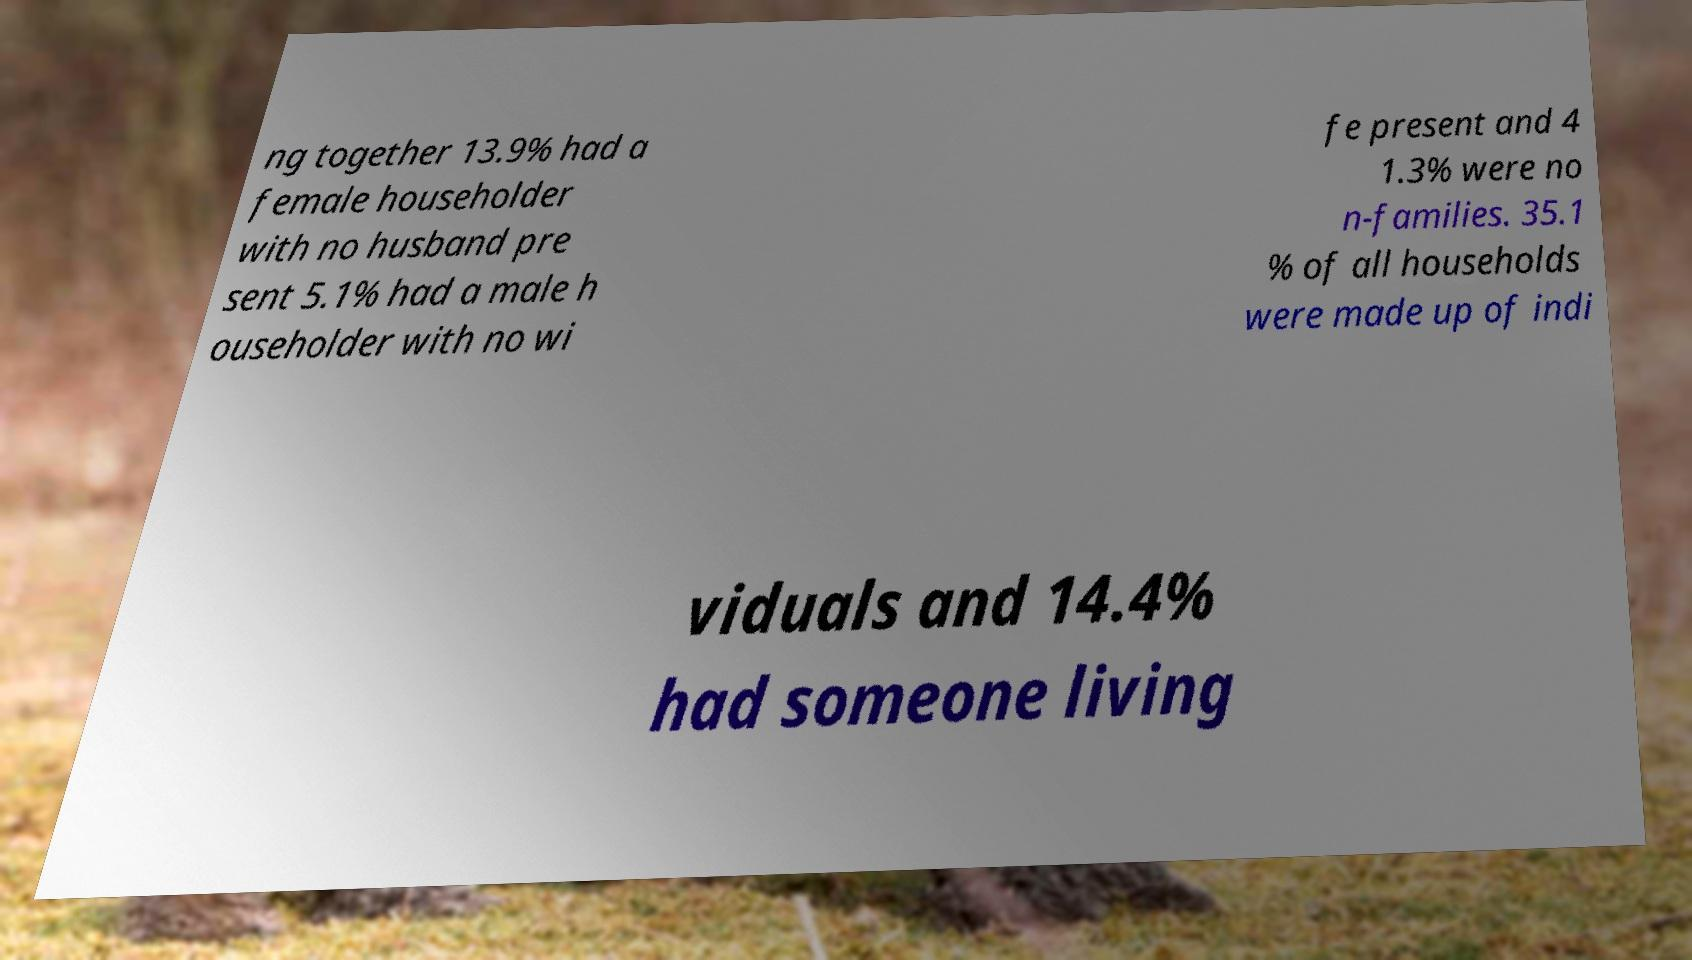Could you extract and type out the text from this image? ng together 13.9% had a female householder with no husband pre sent 5.1% had a male h ouseholder with no wi fe present and 4 1.3% were no n-families. 35.1 % of all households were made up of indi viduals and 14.4% had someone living 